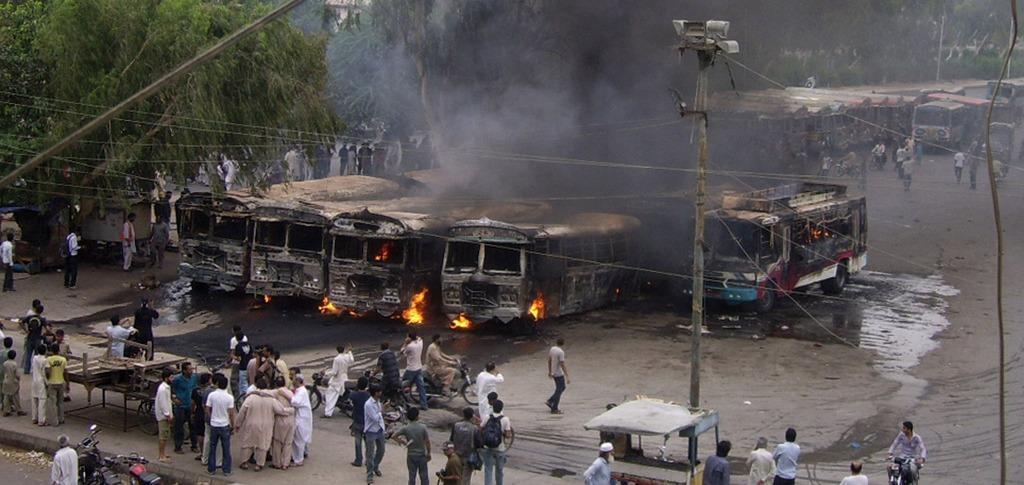Could you give a brief overview of what you see in this image? In the center of the image we can see a few vehicles are burning in the fire. At the bottom of the image, we can see a pole, bikes, few people are standing and a few other objects. Among them, we can see a few people are holding some objects and a few people are riding bikes. In the background, we can see trees, vehicles, few people and a few other objects. 